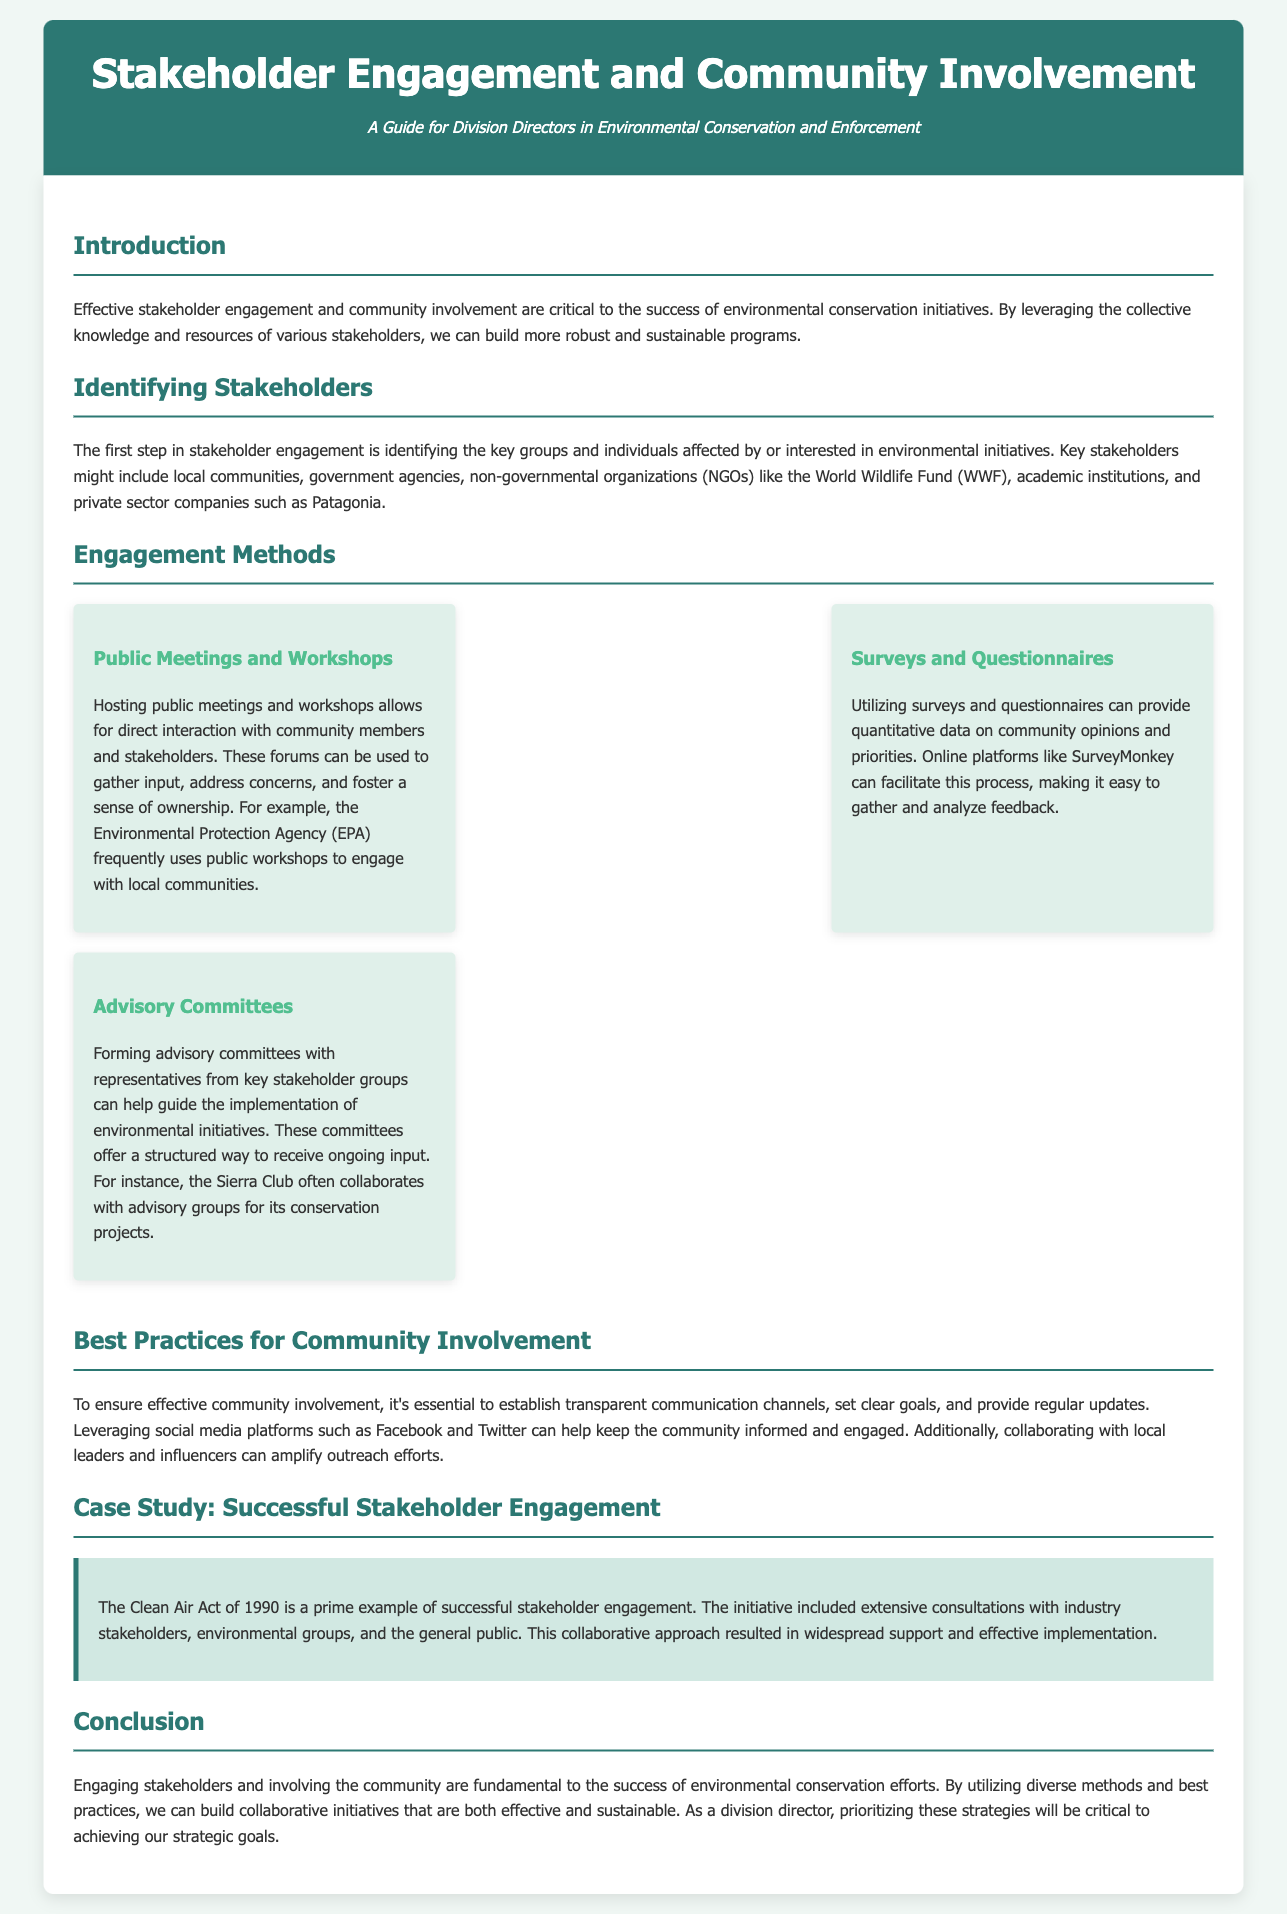what is the title of the guide? The title of the guide is presented in the header section of the document.
Answer: Stakeholder Engagement and Community Involvement who are key stakeholders mentioned in the document? Key stakeholders mentioned include various groups of people involved in environmental initiatives.
Answer: local communities, government agencies, NGOs, academic institutions, private sector companies what engagement method involves direct interaction with the community? This refers to a specific method listed for stakeholder engagement that focuses on community involvement.
Answer: Public Meetings and Workshops which platform is suggested for gathering survey responses? The document mentions a specific online tool for conducting surveys and questionnaires.
Answer: SurveyMonkey what is a best practice for community involvement according to the document? This question looks for an essential practice highlighted for effective community engagement in environmental conservation.
Answer: establish transparent communication channels how did the Clean Air Act of 1990 exemplify stakeholder engagement? This question seeks to summarize the effective stakeholder involvement approach taken in a historical context.
Answer: included extensive consultations what is the main focus of the document? The overall purpose of this guide can be derived from the introduction section.
Answer: effective stakeholder engagement and community involvement what should be prioritized to achieve strategic goals? This question refers to the actions recommended for division directors concerning environmental conservation initiatives.
Answer: engaging stakeholders and involving the community 